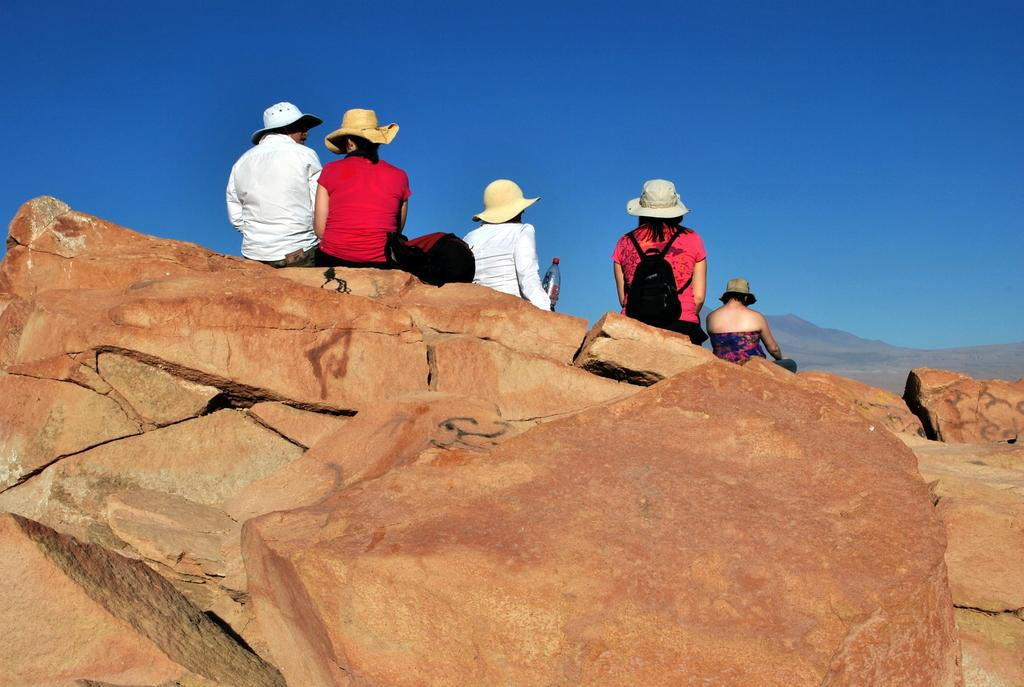Who is present in the image? There are people in the image. What are the people wearing on their heads? The people are wearing hats. Where are the people sitting? The people are sitting on rocks. What can be seen in the distance behind the people? There are mountains in the background of the image. What objects can be seen near the people? There is a bottle and a bag visible in the image. What is visible above the people and mountains? The sky is visible in the background of the image. What type of salt is being used by the daughter in the image? There is no daughter present in the image, and no salt is visible. 